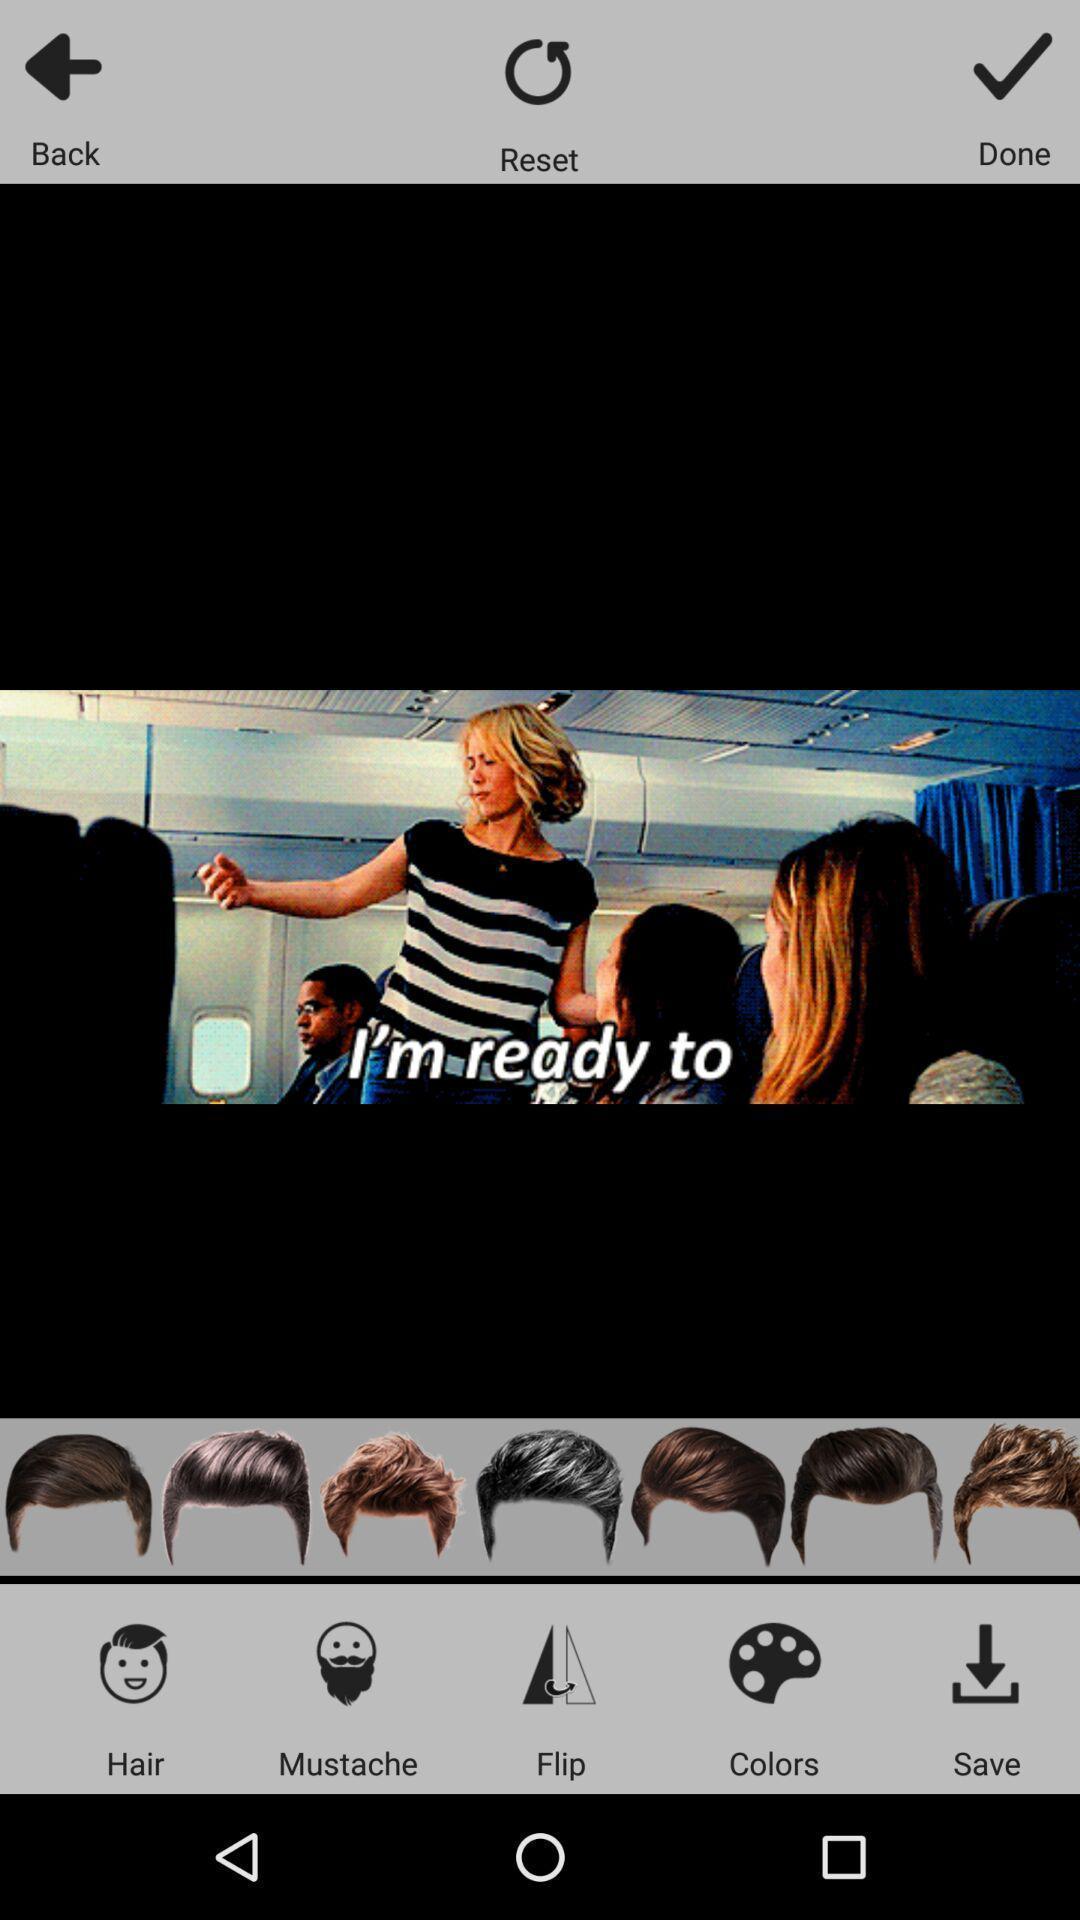Describe this image in words. Screen about image editing options. 